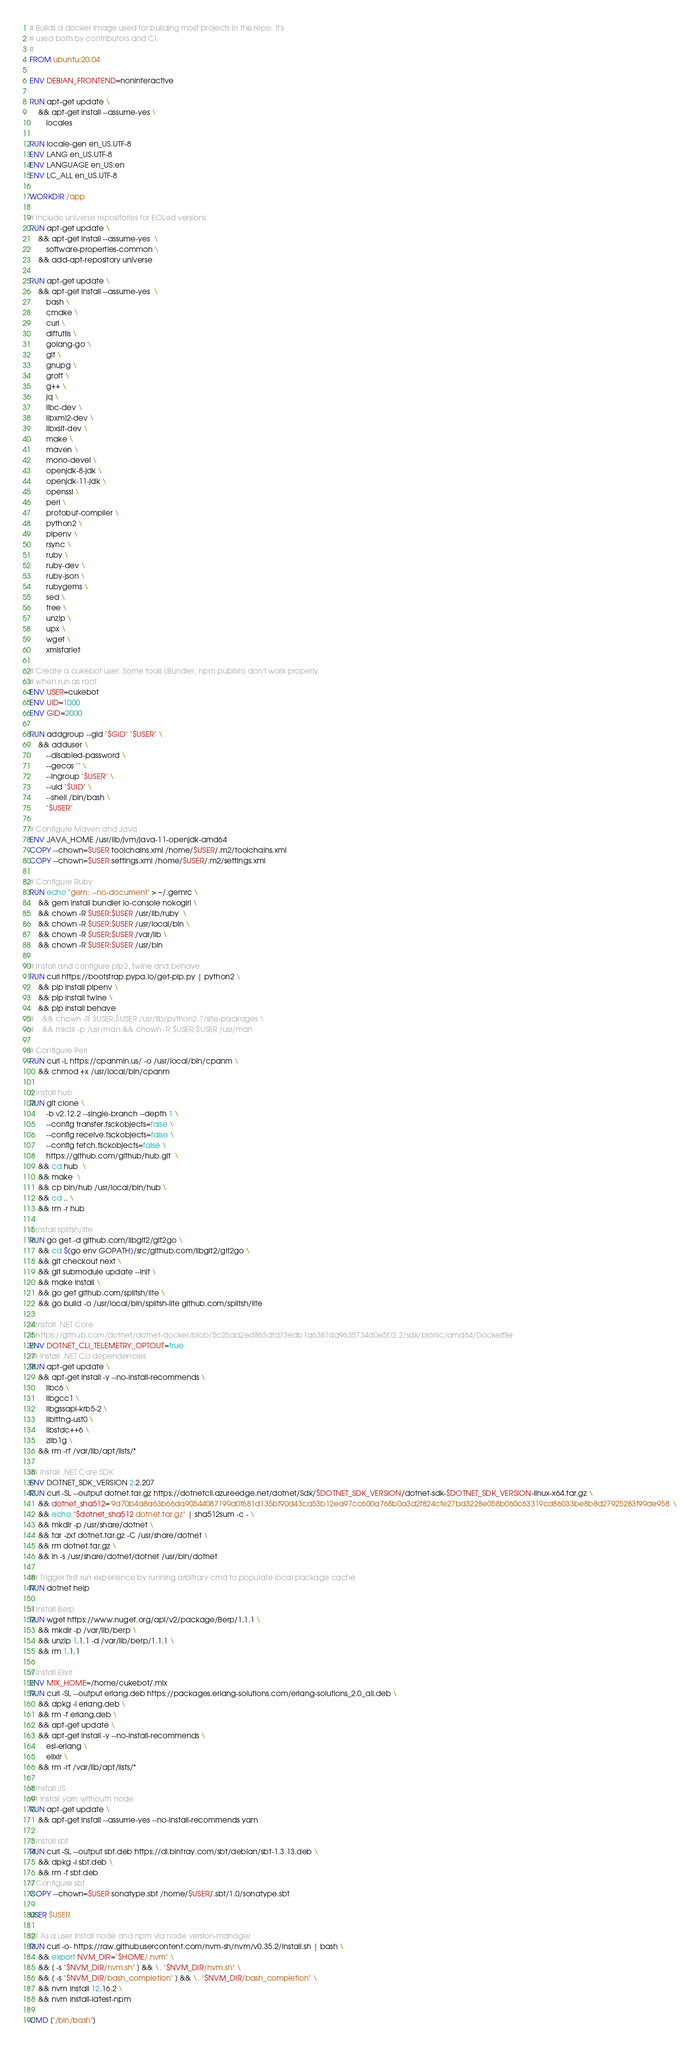<code> <loc_0><loc_0><loc_500><loc_500><_Dockerfile_># Builds a docker image used for building most projects in this repo. It's
# used both by contributors and CI.
#
FROM ubuntu:20.04

ENV DEBIAN_FRONTEND=noninteractive

RUN apt-get update \
    && apt-get install --assume-yes \
        locales

RUN locale-gen en_US.UTF-8
ENV LANG en_US.UTF-8
ENV LANGUAGE en_US:en
ENV LC_ALL en_US.UTF-8

WORKDIR /app

# Include universe repositories for EOLed versions
RUN apt-get update \
    && apt-get install --assume-yes  \
        software-properties-common \
    && add-apt-repository universe

RUN apt-get update \
    && apt-get install --assume-yes  \
        bash \
        cmake \
        curl \
        diffutils \
        golang-go \
        git \
        gnupg \
        groff \
        g++ \
        jq \
        libc-dev \
        libxml2-dev \
        libxslt-dev \
        make \
        maven \
        mono-devel \
        openjdk-8-jdk \
        openjdk-11-jdk \
        openssl \
        perl \
        protobuf-compiler \
        python2 \
        pipenv \
        rsync \
        ruby \
        ruby-dev \
        ruby-json \
        rubygems \
        sed \
        tree \
        unzip \
        upx \
        wget \
        xmlstarlet

# Create a cukebot user. Some tools (Bundler, npm publish) don't work properly
# when run as root
ENV USER=cukebot
ENV UID=1000
ENV GID=2000

RUN addgroup --gid "$GID" "$USER" \
    && adduser \
        --disabled-password \
        --gecos "" \
        --ingroup "$USER" \
        --uid "$UID" \
        --shell /bin/bash \
        "$USER"

# Configure Maven and Java
ENV JAVA_HOME /usr/lib/jvm/java-11-openjdk-amd64
COPY --chown=$USER toolchains.xml /home/$USER/.m2/toolchains.xml
COPY --chown=$USER settings.xml /home/$USER/.m2/settings.xml

# Configure Ruby
RUN echo "gem: --no-document" > ~/.gemrc \
    && gem install bundler io-console nokogiri \
    && chown -R $USER:$USER /usr/lib/ruby  \
    && chown -R $USER:$USER /usr/local/bin \
    && chown -R $USER:$USER /var/lib \
    && chown -R $USER:$USER /usr/bin

# Install and configure pip2, twine and behave
RUN curl https://bootstrap.pypa.io/get-pip.py | python2 \
    && pip install pipenv \
    && pip install twine \
    && pip install behave
#    && chown -R $USER:$USER /usr/lib/python2.7/site-packages \
#    && mkdir -p /usr/man && chown -R $USER:$USER /usr/man

# Configure Perl
RUN curl -L https://cpanmin.us/ -o /usr/local/bin/cpanm \
    && chmod +x /usr/local/bin/cpanm

# Install hub
RUN git clone \
        -b v2.12.2 --single-branch --depth 1 \
        --config transfer.fsckobjects=false \
        --config receive.fsckobjects=false \
        --config fetch.fsckobjects=false \
        https://github.com/github/hub.git  \
    && cd hub  \
    && make  \
    && cp bin/hub /usr/local/bin/hub \
    && cd .. \
    && rm -r hub

# Install splitsh/lite
RUN go get -d github.com/libgit2/git2go \
    && cd $(go env GOPATH)/src/github.com/libgit2/git2go \
    && git checkout next \
    && git submodule update --init \
    && make install \
    && go get github.com/splitsh/lite \
    && go build -o /usr/local/bin/splitsh-lite github.com/splitsh/lite

# Install .NET Core
# https://github.com/dotnet/dotnet-docker/blob/5c25dd2ed863dfd73edb1a6381dd9635734d0e5f/2.2/sdk/bionic/amd64/Dockerfile
ENV DOTNET_CLI_TELEMETRY_OPTOUT=true
## Install .NET CLI dependencies
RUN apt-get update \
    && apt-get install -y --no-install-recommends \
        libc6 \
        libgcc1 \
        libgssapi-krb5-2 \
        liblttng-ust0 \
        libstdc++6 \
        zlib1g \
    && rm -rf /var/lib/apt/lists/*

## Install .NET Core SDK
ENV DOTNET_SDK_VERSION 2.2.207
RUN curl -SL --output dotnet.tar.gz https://dotnetcli.azureedge.net/dotnet/Sdk/$DOTNET_SDK_VERSION/dotnet-sdk-$DOTNET_SDK_VERSION-linux-x64.tar.gz \
    && dotnet_sha512='9d70b4a8a63b66da90544087199a0f681d135bf90d43ca53b12ea97cc600a768b0a3d2f824cfe27bd3228e058b060c63319cd86033be8b8d27925283f99de958' \
    && echo "$dotnet_sha512 dotnet.tar.gz" | sha512sum -c - \
    && mkdir -p /usr/share/dotnet \
    && tar -zxf dotnet.tar.gz -C /usr/share/dotnet \
    && rm dotnet.tar.gz \
    && ln -s /usr/share/dotnet/dotnet /usr/bin/dotnet

## Trigger first run experience by running arbitrary cmd to populate local package cache
RUN dotnet help

# Install Berp
RUN wget https://www.nuget.org/api/v2/package/Berp/1.1.1 \
    && mkdir -p /var/lib/berp \
    && unzip 1.1.1 -d /var/lib/berp/1.1.1 \
    && rm 1.1.1

# Install Elixir
ENV MIX_HOME=/home/cukebot/.mix
RUN curl -SL --output erlang.deb https://packages.erlang-solutions.com/erlang-solutions_2.0_all.deb \
    && dpkg -i erlang.deb \
    && rm -f erlang.deb \
    && apt-get update \
    && apt-get install -y --no-install-recommends \
        esl-erlang \
        elixir \
    && rm -rf /var/lib/apt/lists/*

# Install JS
## Install yarn withouth node
RUN apt-get update \
    && apt-get install --assume-yes --no-install-recommends yarn

# Install sbt
RUN curl -SL --output sbt.deb https://dl.bintray.com/sbt/debian/sbt-1.3.13.deb \
    && dpkg -i sbt.deb \
    && rm -f sbt.deb 
# Configure sbt
COPY --chown=$USER sonatype.sbt /home/$USER/.sbt/1.0/sonatype.sbt

USER $USER

## As a user install node and npm via node version-manager
RUN curl -o- https://raw.githubusercontent.com/nvm-sh/nvm/v0.35.2/install.sh | bash \
    && export NVM_DIR="$HOME/.nvm" \
    && [ -s "$NVM_DIR/nvm.sh" ] && \. "$NVM_DIR/nvm.sh" \
    && [ -s "$NVM_DIR/bash_completion" ] && \. "$NVM_DIR/bash_completion" \
    && nvm install 12.16.2 \
    && nvm install-latest-npm

CMD ["/bin/bash"]
</code> 